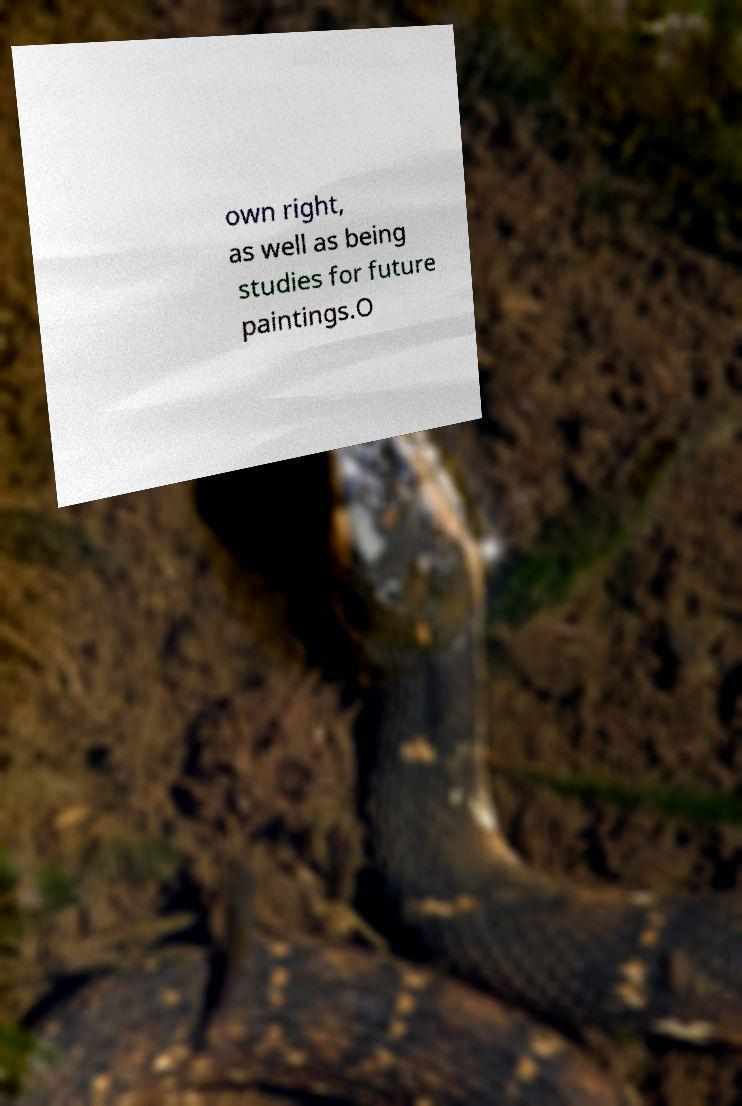Can you accurately transcribe the text from the provided image for me? own right, as well as being studies for future paintings.O 